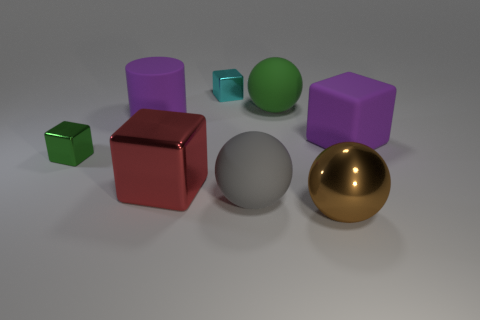Add 2 large gray cylinders. How many objects exist? 10 Subtract all spheres. How many objects are left? 5 Subtract 0 brown cylinders. How many objects are left? 8 Subtract all red metallic things. Subtract all tiny gray matte cylinders. How many objects are left? 7 Add 1 large green things. How many large green things are left? 2 Add 3 large yellow rubber things. How many large yellow rubber things exist? 3 